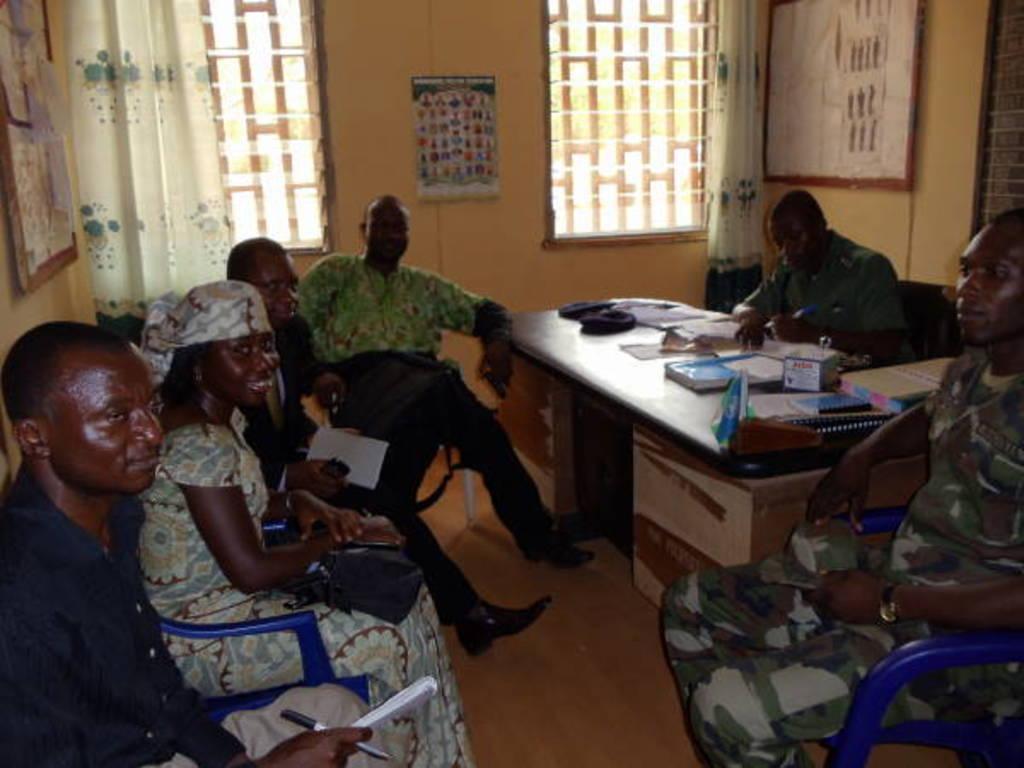Could you give a brief overview of what you see in this image? This persons are sitting on a chair. In-front of this person there is a table, on a table there is a book and box. Chart is attached to a wall. This are posters on wall. A window with curtain. 